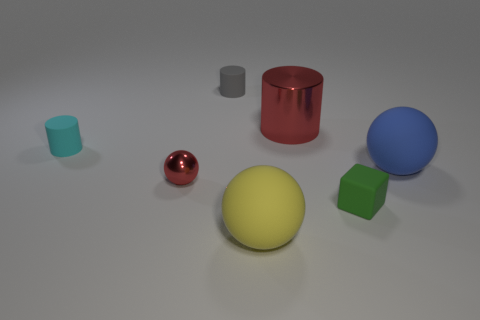Add 1 matte cubes. How many objects exist? 8 Subtract all small red balls. How many balls are left? 2 Subtract all red spheres. How many spheres are left? 2 Subtract all cylinders. How many objects are left? 4 Subtract 1 balls. How many balls are left? 2 Subtract all blue cylinders. Subtract all gray spheres. How many cylinders are left? 3 Subtract all red balls. How many red cylinders are left? 1 Subtract all large green spheres. Subtract all red metallic things. How many objects are left? 5 Add 4 small gray cylinders. How many small gray cylinders are left? 5 Add 5 purple metallic cylinders. How many purple metallic cylinders exist? 5 